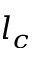<formula> <loc_0><loc_0><loc_500><loc_500>l _ { c }</formula> 